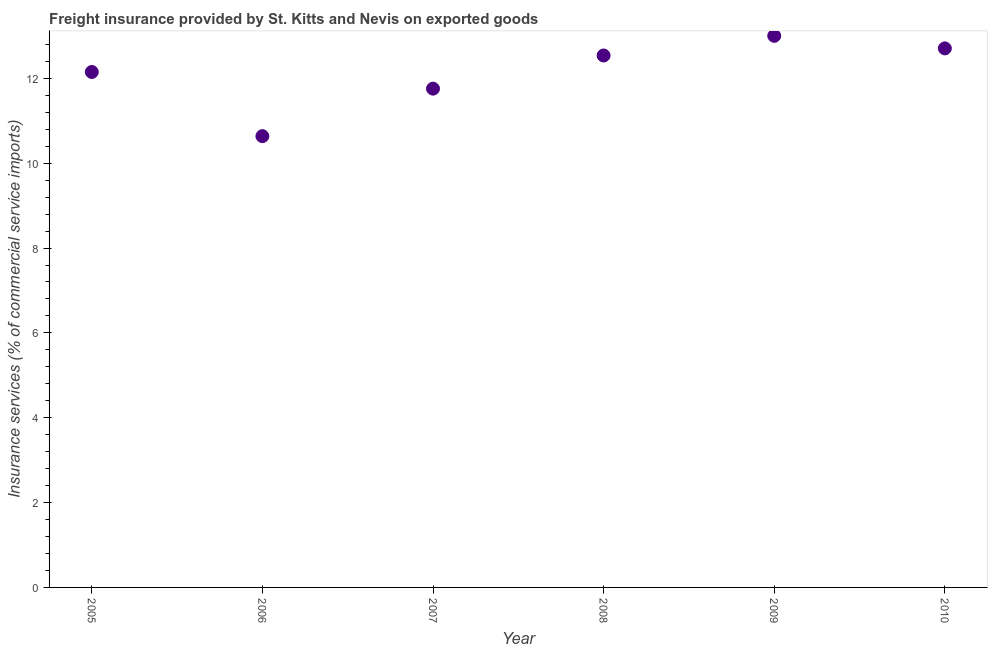What is the freight insurance in 2005?
Provide a succinct answer. 12.15. Across all years, what is the maximum freight insurance?
Your answer should be compact. 13. Across all years, what is the minimum freight insurance?
Provide a succinct answer. 10.64. In which year was the freight insurance maximum?
Provide a short and direct response. 2009. In which year was the freight insurance minimum?
Offer a terse response. 2006. What is the sum of the freight insurance?
Your answer should be very brief. 72.79. What is the difference between the freight insurance in 2006 and 2010?
Provide a succinct answer. -2.07. What is the average freight insurance per year?
Ensure brevity in your answer.  12.13. What is the median freight insurance?
Your answer should be compact. 12.34. Do a majority of the years between 2005 and 2008 (inclusive) have freight insurance greater than 10.8 %?
Your answer should be compact. Yes. What is the ratio of the freight insurance in 2006 to that in 2007?
Make the answer very short. 0.9. Is the freight insurance in 2008 less than that in 2010?
Ensure brevity in your answer.  Yes. What is the difference between the highest and the second highest freight insurance?
Your answer should be very brief. 0.3. Is the sum of the freight insurance in 2006 and 2008 greater than the maximum freight insurance across all years?
Your response must be concise. Yes. What is the difference between the highest and the lowest freight insurance?
Keep it short and to the point. 2.36. In how many years, is the freight insurance greater than the average freight insurance taken over all years?
Provide a short and direct response. 4. Does the freight insurance monotonically increase over the years?
Provide a succinct answer. No. How many dotlines are there?
Make the answer very short. 1. Are the values on the major ticks of Y-axis written in scientific E-notation?
Ensure brevity in your answer.  No. Does the graph contain any zero values?
Make the answer very short. No. Does the graph contain grids?
Offer a very short reply. No. What is the title of the graph?
Your response must be concise. Freight insurance provided by St. Kitts and Nevis on exported goods . What is the label or title of the X-axis?
Give a very brief answer. Year. What is the label or title of the Y-axis?
Your response must be concise. Insurance services (% of commercial service imports). What is the Insurance services (% of commercial service imports) in 2005?
Your response must be concise. 12.15. What is the Insurance services (% of commercial service imports) in 2006?
Your response must be concise. 10.64. What is the Insurance services (% of commercial service imports) in 2007?
Provide a short and direct response. 11.76. What is the Insurance services (% of commercial service imports) in 2008?
Offer a terse response. 12.54. What is the Insurance services (% of commercial service imports) in 2009?
Your response must be concise. 13. What is the Insurance services (% of commercial service imports) in 2010?
Give a very brief answer. 12.71. What is the difference between the Insurance services (% of commercial service imports) in 2005 and 2006?
Make the answer very short. 1.51. What is the difference between the Insurance services (% of commercial service imports) in 2005 and 2007?
Give a very brief answer. 0.39. What is the difference between the Insurance services (% of commercial service imports) in 2005 and 2008?
Keep it short and to the point. -0.39. What is the difference between the Insurance services (% of commercial service imports) in 2005 and 2009?
Provide a succinct answer. -0.85. What is the difference between the Insurance services (% of commercial service imports) in 2005 and 2010?
Keep it short and to the point. -0.56. What is the difference between the Insurance services (% of commercial service imports) in 2006 and 2007?
Provide a short and direct response. -1.12. What is the difference between the Insurance services (% of commercial service imports) in 2006 and 2008?
Offer a very short reply. -1.9. What is the difference between the Insurance services (% of commercial service imports) in 2006 and 2009?
Your response must be concise. -2.36. What is the difference between the Insurance services (% of commercial service imports) in 2006 and 2010?
Provide a short and direct response. -2.07. What is the difference between the Insurance services (% of commercial service imports) in 2007 and 2008?
Your answer should be compact. -0.78. What is the difference between the Insurance services (% of commercial service imports) in 2007 and 2009?
Offer a terse response. -1.24. What is the difference between the Insurance services (% of commercial service imports) in 2007 and 2010?
Provide a short and direct response. -0.95. What is the difference between the Insurance services (% of commercial service imports) in 2008 and 2009?
Make the answer very short. -0.46. What is the difference between the Insurance services (% of commercial service imports) in 2008 and 2010?
Your answer should be compact. -0.17. What is the difference between the Insurance services (% of commercial service imports) in 2009 and 2010?
Offer a very short reply. 0.3. What is the ratio of the Insurance services (% of commercial service imports) in 2005 to that in 2006?
Give a very brief answer. 1.14. What is the ratio of the Insurance services (% of commercial service imports) in 2005 to that in 2007?
Give a very brief answer. 1.03. What is the ratio of the Insurance services (% of commercial service imports) in 2005 to that in 2009?
Offer a terse response. 0.93. What is the ratio of the Insurance services (% of commercial service imports) in 2005 to that in 2010?
Offer a very short reply. 0.96. What is the ratio of the Insurance services (% of commercial service imports) in 2006 to that in 2007?
Your response must be concise. 0.91. What is the ratio of the Insurance services (% of commercial service imports) in 2006 to that in 2008?
Give a very brief answer. 0.85. What is the ratio of the Insurance services (% of commercial service imports) in 2006 to that in 2009?
Give a very brief answer. 0.82. What is the ratio of the Insurance services (% of commercial service imports) in 2006 to that in 2010?
Your answer should be compact. 0.84. What is the ratio of the Insurance services (% of commercial service imports) in 2007 to that in 2008?
Your answer should be very brief. 0.94. What is the ratio of the Insurance services (% of commercial service imports) in 2007 to that in 2009?
Your answer should be compact. 0.9. What is the ratio of the Insurance services (% of commercial service imports) in 2007 to that in 2010?
Keep it short and to the point. 0.93. 